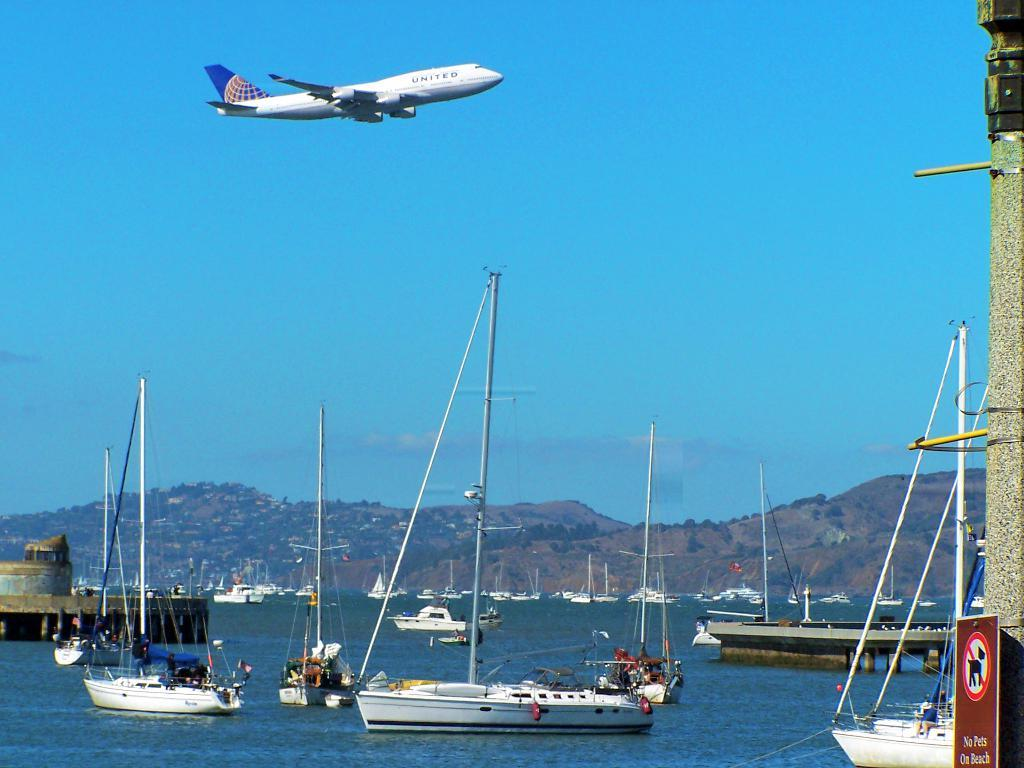<image>
Share a concise interpretation of the image provided. A United Airlines plane flies over a beautiful marina full of boats. 